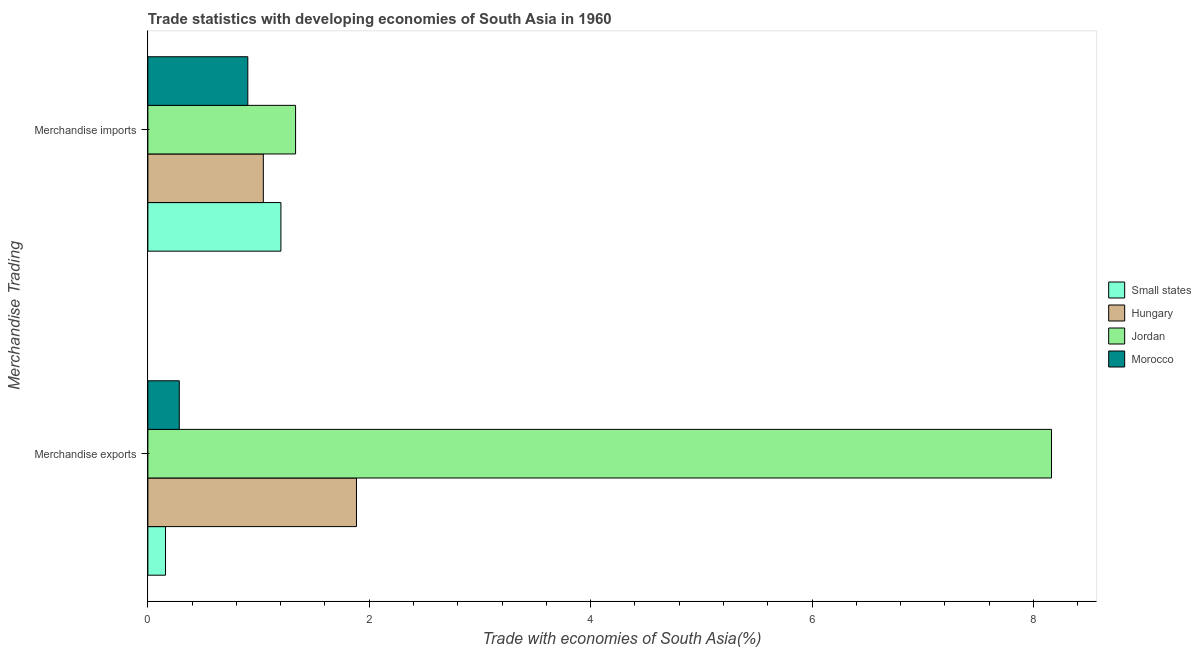Are the number of bars per tick equal to the number of legend labels?
Give a very brief answer. Yes. How many bars are there on the 2nd tick from the bottom?
Make the answer very short. 4. What is the merchandise exports in Morocco?
Keep it short and to the point. 0.28. Across all countries, what is the maximum merchandise imports?
Ensure brevity in your answer.  1.33. Across all countries, what is the minimum merchandise exports?
Ensure brevity in your answer.  0.16. In which country was the merchandise imports maximum?
Keep it short and to the point. Jordan. In which country was the merchandise exports minimum?
Ensure brevity in your answer.  Small states. What is the total merchandise exports in the graph?
Give a very brief answer. 10.49. What is the difference between the merchandise imports in Hungary and that in Morocco?
Offer a very short reply. 0.14. What is the difference between the merchandise exports in Morocco and the merchandise imports in Small states?
Provide a short and direct response. -0.92. What is the average merchandise imports per country?
Your answer should be compact. 1.12. What is the difference between the merchandise exports and merchandise imports in Small states?
Offer a terse response. -1.04. What is the ratio of the merchandise imports in Jordan to that in Morocco?
Provide a succinct answer. 1.48. In how many countries, is the merchandise exports greater than the average merchandise exports taken over all countries?
Offer a very short reply. 1. What does the 1st bar from the top in Merchandise imports represents?
Keep it short and to the point. Morocco. What does the 3rd bar from the bottom in Merchandise exports represents?
Your answer should be compact. Jordan. Are all the bars in the graph horizontal?
Keep it short and to the point. Yes. Does the graph contain grids?
Offer a very short reply. No. Where does the legend appear in the graph?
Ensure brevity in your answer.  Center right. How many legend labels are there?
Keep it short and to the point. 4. How are the legend labels stacked?
Your response must be concise. Vertical. What is the title of the graph?
Keep it short and to the point. Trade statistics with developing economies of South Asia in 1960. What is the label or title of the X-axis?
Your answer should be very brief. Trade with economies of South Asia(%). What is the label or title of the Y-axis?
Make the answer very short. Merchandise Trading. What is the Trade with economies of South Asia(%) in Small states in Merchandise exports?
Offer a terse response. 0.16. What is the Trade with economies of South Asia(%) in Hungary in Merchandise exports?
Keep it short and to the point. 1.88. What is the Trade with economies of South Asia(%) in Jordan in Merchandise exports?
Your answer should be very brief. 8.16. What is the Trade with economies of South Asia(%) of Morocco in Merchandise exports?
Offer a terse response. 0.28. What is the Trade with economies of South Asia(%) of Small states in Merchandise imports?
Offer a very short reply. 1.2. What is the Trade with economies of South Asia(%) in Hungary in Merchandise imports?
Provide a succinct answer. 1.04. What is the Trade with economies of South Asia(%) of Jordan in Merchandise imports?
Make the answer very short. 1.33. What is the Trade with economies of South Asia(%) of Morocco in Merchandise imports?
Provide a succinct answer. 0.9. Across all Merchandise Trading, what is the maximum Trade with economies of South Asia(%) in Small states?
Make the answer very short. 1.2. Across all Merchandise Trading, what is the maximum Trade with economies of South Asia(%) in Hungary?
Your answer should be compact. 1.88. Across all Merchandise Trading, what is the maximum Trade with economies of South Asia(%) of Jordan?
Provide a succinct answer. 8.16. Across all Merchandise Trading, what is the maximum Trade with economies of South Asia(%) in Morocco?
Ensure brevity in your answer.  0.9. Across all Merchandise Trading, what is the minimum Trade with economies of South Asia(%) in Small states?
Provide a succinct answer. 0.16. Across all Merchandise Trading, what is the minimum Trade with economies of South Asia(%) of Hungary?
Your answer should be compact. 1.04. Across all Merchandise Trading, what is the minimum Trade with economies of South Asia(%) in Jordan?
Provide a succinct answer. 1.33. Across all Merchandise Trading, what is the minimum Trade with economies of South Asia(%) of Morocco?
Provide a succinct answer. 0.28. What is the total Trade with economies of South Asia(%) in Small states in the graph?
Offer a terse response. 1.36. What is the total Trade with economies of South Asia(%) of Hungary in the graph?
Keep it short and to the point. 2.93. What is the total Trade with economies of South Asia(%) of Jordan in the graph?
Give a very brief answer. 9.5. What is the total Trade with economies of South Asia(%) of Morocco in the graph?
Offer a terse response. 1.19. What is the difference between the Trade with economies of South Asia(%) in Small states in Merchandise exports and that in Merchandise imports?
Your answer should be compact. -1.04. What is the difference between the Trade with economies of South Asia(%) of Hungary in Merchandise exports and that in Merchandise imports?
Offer a very short reply. 0.84. What is the difference between the Trade with economies of South Asia(%) of Jordan in Merchandise exports and that in Merchandise imports?
Provide a succinct answer. 6.83. What is the difference between the Trade with economies of South Asia(%) of Morocco in Merchandise exports and that in Merchandise imports?
Offer a terse response. -0.62. What is the difference between the Trade with economies of South Asia(%) in Small states in Merchandise exports and the Trade with economies of South Asia(%) in Hungary in Merchandise imports?
Make the answer very short. -0.88. What is the difference between the Trade with economies of South Asia(%) in Small states in Merchandise exports and the Trade with economies of South Asia(%) in Jordan in Merchandise imports?
Ensure brevity in your answer.  -1.18. What is the difference between the Trade with economies of South Asia(%) of Small states in Merchandise exports and the Trade with economies of South Asia(%) of Morocco in Merchandise imports?
Provide a succinct answer. -0.74. What is the difference between the Trade with economies of South Asia(%) in Hungary in Merchandise exports and the Trade with economies of South Asia(%) in Jordan in Merchandise imports?
Ensure brevity in your answer.  0.55. What is the difference between the Trade with economies of South Asia(%) of Hungary in Merchandise exports and the Trade with economies of South Asia(%) of Morocco in Merchandise imports?
Give a very brief answer. 0.98. What is the difference between the Trade with economies of South Asia(%) in Jordan in Merchandise exports and the Trade with economies of South Asia(%) in Morocco in Merchandise imports?
Offer a very short reply. 7.26. What is the average Trade with economies of South Asia(%) of Small states per Merchandise Trading?
Offer a very short reply. 0.68. What is the average Trade with economies of South Asia(%) in Hungary per Merchandise Trading?
Provide a short and direct response. 1.46. What is the average Trade with economies of South Asia(%) of Jordan per Merchandise Trading?
Make the answer very short. 4.75. What is the average Trade with economies of South Asia(%) in Morocco per Merchandise Trading?
Give a very brief answer. 0.59. What is the difference between the Trade with economies of South Asia(%) in Small states and Trade with economies of South Asia(%) in Hungary in Merchandise exports?
Keep it short and to the point. -1.73. What is the difference between the Trade with economies of South Asia(%) in Small states and Trade with economies of South Asia(%) in Jordan in Merchandise exports?
Your answer should be very brief. -8. What is the difference between the Trade with economies of South Asia(%) in Small states and Trade with economies of South Asia(%) in Morocco in Merchandise exports?
Ensure brevity in your answer.  -0.12. What is the difference between the Trade with economies of South Asia(%) of Hungary and Trade with economies of South Asia(%) of Jordan in Merchandise exports?
Give a very brief answer. -6.28. What is the difference between the Trade with economies of South Asia(%) of Hungary and Trade with economies of South Asia(%) of Morocco in Merchandise exports?
Give a very brief answer. 1.6. What is the difference between the Trade with economies of South Asia(%) in Jordan and Trade with economies of South Asia(%) in Morocco in Merchandise exports?
Provide a succinct answer. 7.88. What is the difference between the Trade with economies of South Asia(%) in Small states and Trade with economies of South Asia(%) in Hungary in Merchandise imports?
Offer a very short reply. 0.16. What is the difference between the Trade with economies of South Asia(%) of Small states and Trade with economies of South Asia(%) of Jordan in Merchandise imports?
Provide a short and direct response. -0.13. What is the difference between the Trade with economies of South Asia(%) of Small states and Trade with economies of South Asia(%) of Morocco in Merchandise imports?
Your answer should be compact. 0.3. What is the difference between the Trade with economies of South Asia(%) of Hungary and Trade with economies of South Asia(%) of Jordan in Merchandise imports?
Provide a succinct answer. -0.29. What is the difference between the Trade with economies of South Asia(%) of Hungary and Trade with economies of South Asia(%) of Morocco in Merchandise imports?
Make the answer very short. 0.14. What is the difference between the Trade with economies of South Asia(%) of Jordan and Trade with economies of South Asia(%) of Morocco in Merchandise imports?
Provide a short and direct response. 0.43. What is the ratio of the Trade with economies of South Asia(%) in Small states in Merchandise exports to that in Merchandise imports?
Provide a short and direct response. 0.13. What is the ratio of the Trade with economies of South Asia(%) in Hungary in Merchandise exports to that in Merchandise imports?
Keep it short and to the point. 1.81. What is the ratio of the Trade with economies of South Asia(%) in Jordan in Merchandise exports to that in Merchandise imports?
Ensure brevity in your answer.  6.12. What is the ratio of the Trade with economies of South Asia(%) of Morocco in Merchandise exports to that in Merchandise imports?
Offer a terse response. 0.31. What is the difference between the highest and the second highest Trade with economies of South Asia(%) of Small states?
Keep it short and to the point. 1.04. What is the difference between the highest and the second highest Trade with economies of South Asia(%) in Hungary?
Ensure brevity in your answer.  0.84. What is the difference between the highest and the second highest Trade with economies of South Asia(%) of Jordan?
Offer a very short reply. 6.83. What is the difference between the highest and the second highest Trade with economies of South Asia(%) in Morocco?
Offer a very short reply. 0.62. What is the difference between the highest and the lowest Trade with economies of South Asia(%) in Small states?
Your answer should be compact. 1.04. What is the difference between the highest and the lowest Trade with economies of South Asia(%) of Hungary?
Make the answer very short. 0.84. What is the difference between the highest and the lowest Trade with economies of South Asia(%) of Jordan?
Ensure brevity in your answer.  6.83. What is the difference between the highest and the lowest Trade with economies of South Asia(%) of Morocco?
Offer a terse response. 0.62. 